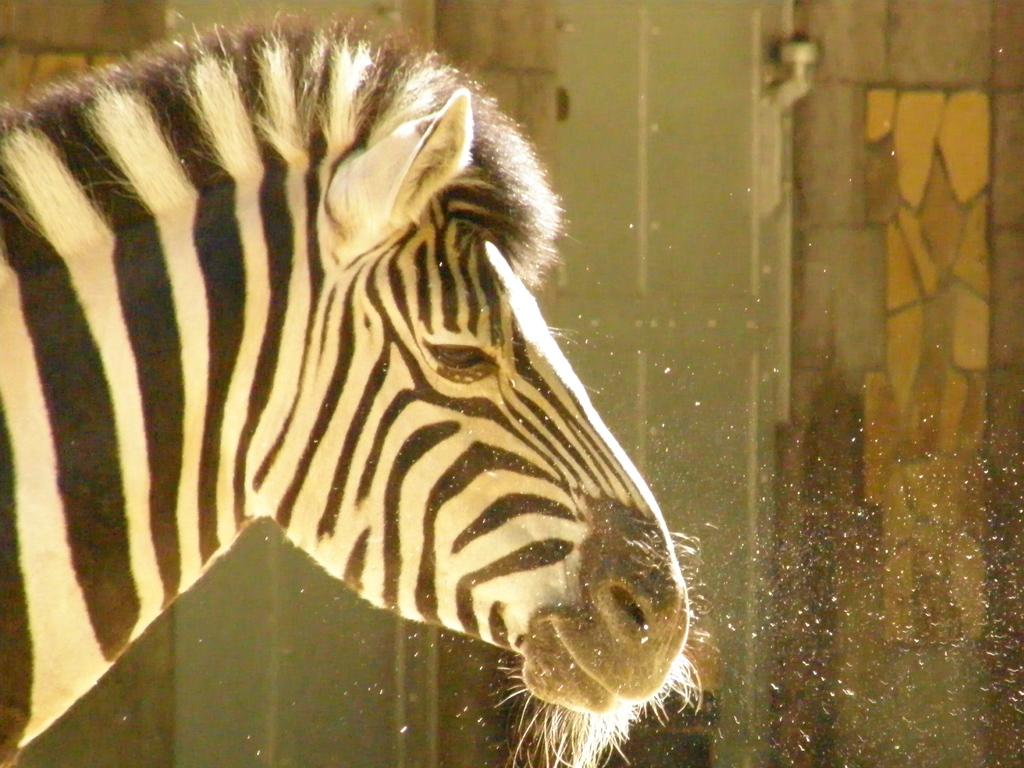What animal's face is depicted in the image? There is a zebra's face in the image. What type of dinosaurs can be seen in the image? There are no dinosaurs present in the image; it features a zebra's face. What kind of agreement is being made in the image? There is no agreement being made in the image; it features a zebra's face. 